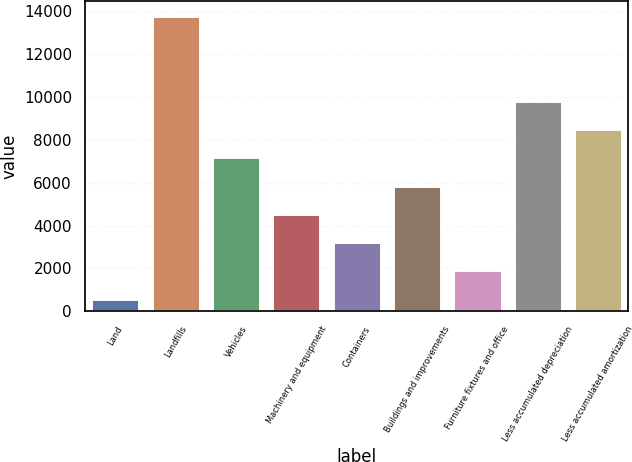Convert chart to OTSL. <chart><loc_0><loc_0><loc_500><loc_500><bar_chart><fcel>Land<fcel>Landfills<fcel>Vehicles<fcel>Machinery and equipment<fcel>Containers<fcel>Buildings and improvements<fcel>Furniture fixtures and office<fcel>Less accumulated depreciation<fcel>Less accumulated amortization<nl><fcel>592<fcel>13772<fcel>7182<fcel>4546<fcel>3228<fcel>5864<fcel>1910<fcel>9818<fcel>8500<nl></chart> 